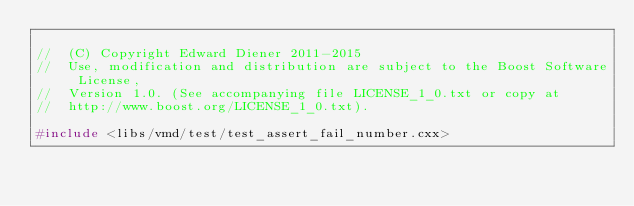<code> <loc_0><loc_0><loc_500><loc_500><_C++_>
//  (C) Copyright Edward Diener 2011-2015
//  Use, modification and distribution are subject to the Boost Software License,
//  Version 1.0. (See accompanying file LICENSE_1_0.txt or copy at
//  http://www.boost.org/LICENSE_1_0.txt).

#include <libs/vmd/test/test_assert_fail_number.cxx>
</code> 